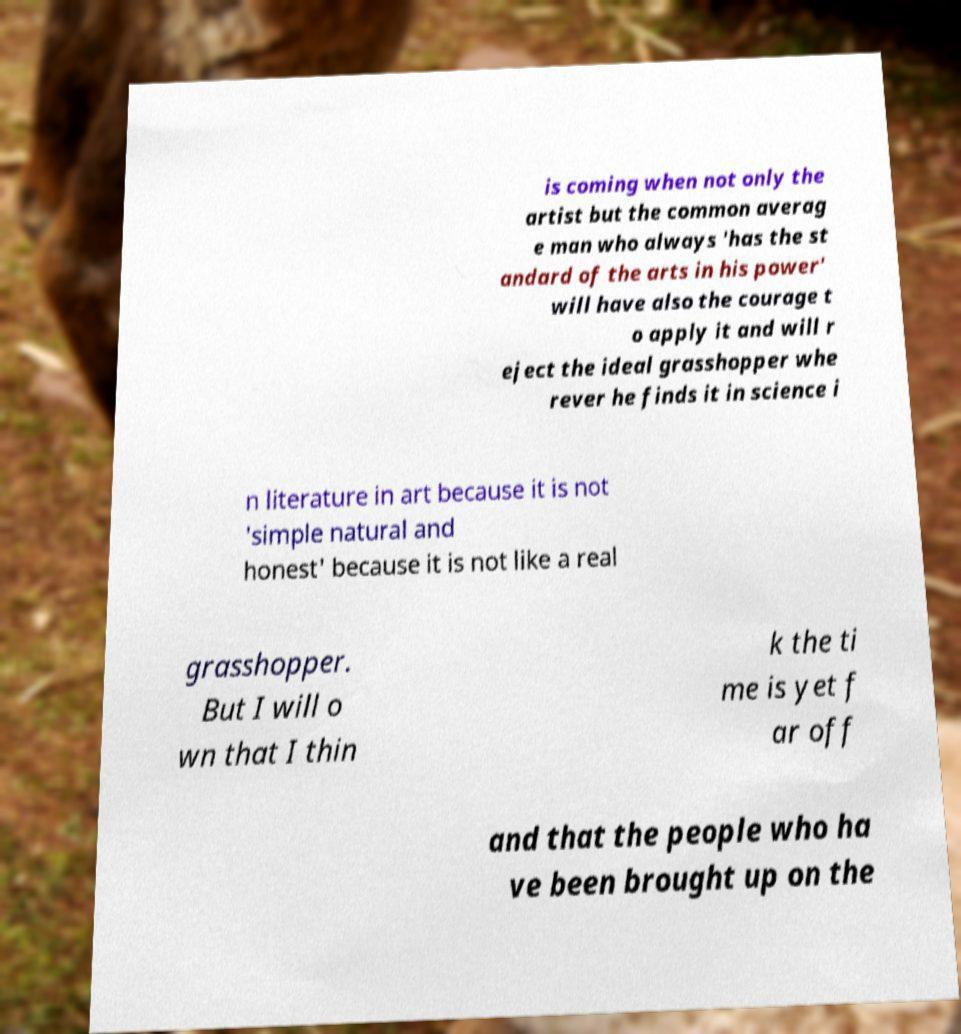What messages or text are displayed in this image? I need them in a readable, typed format. is coming when not only the artist but the common averag e man who always 'has the st andard of the arts in his power' will have also the courage t o apply it and will r eject the ideal grasshopper whe rever he finds it in science i n literature in art because it is not 'simple natural and honest' because it is not like a real grasshopper. But I will o wn that I thin k the ti me is yet f ar off and that the people who ha ve been brought up on the 